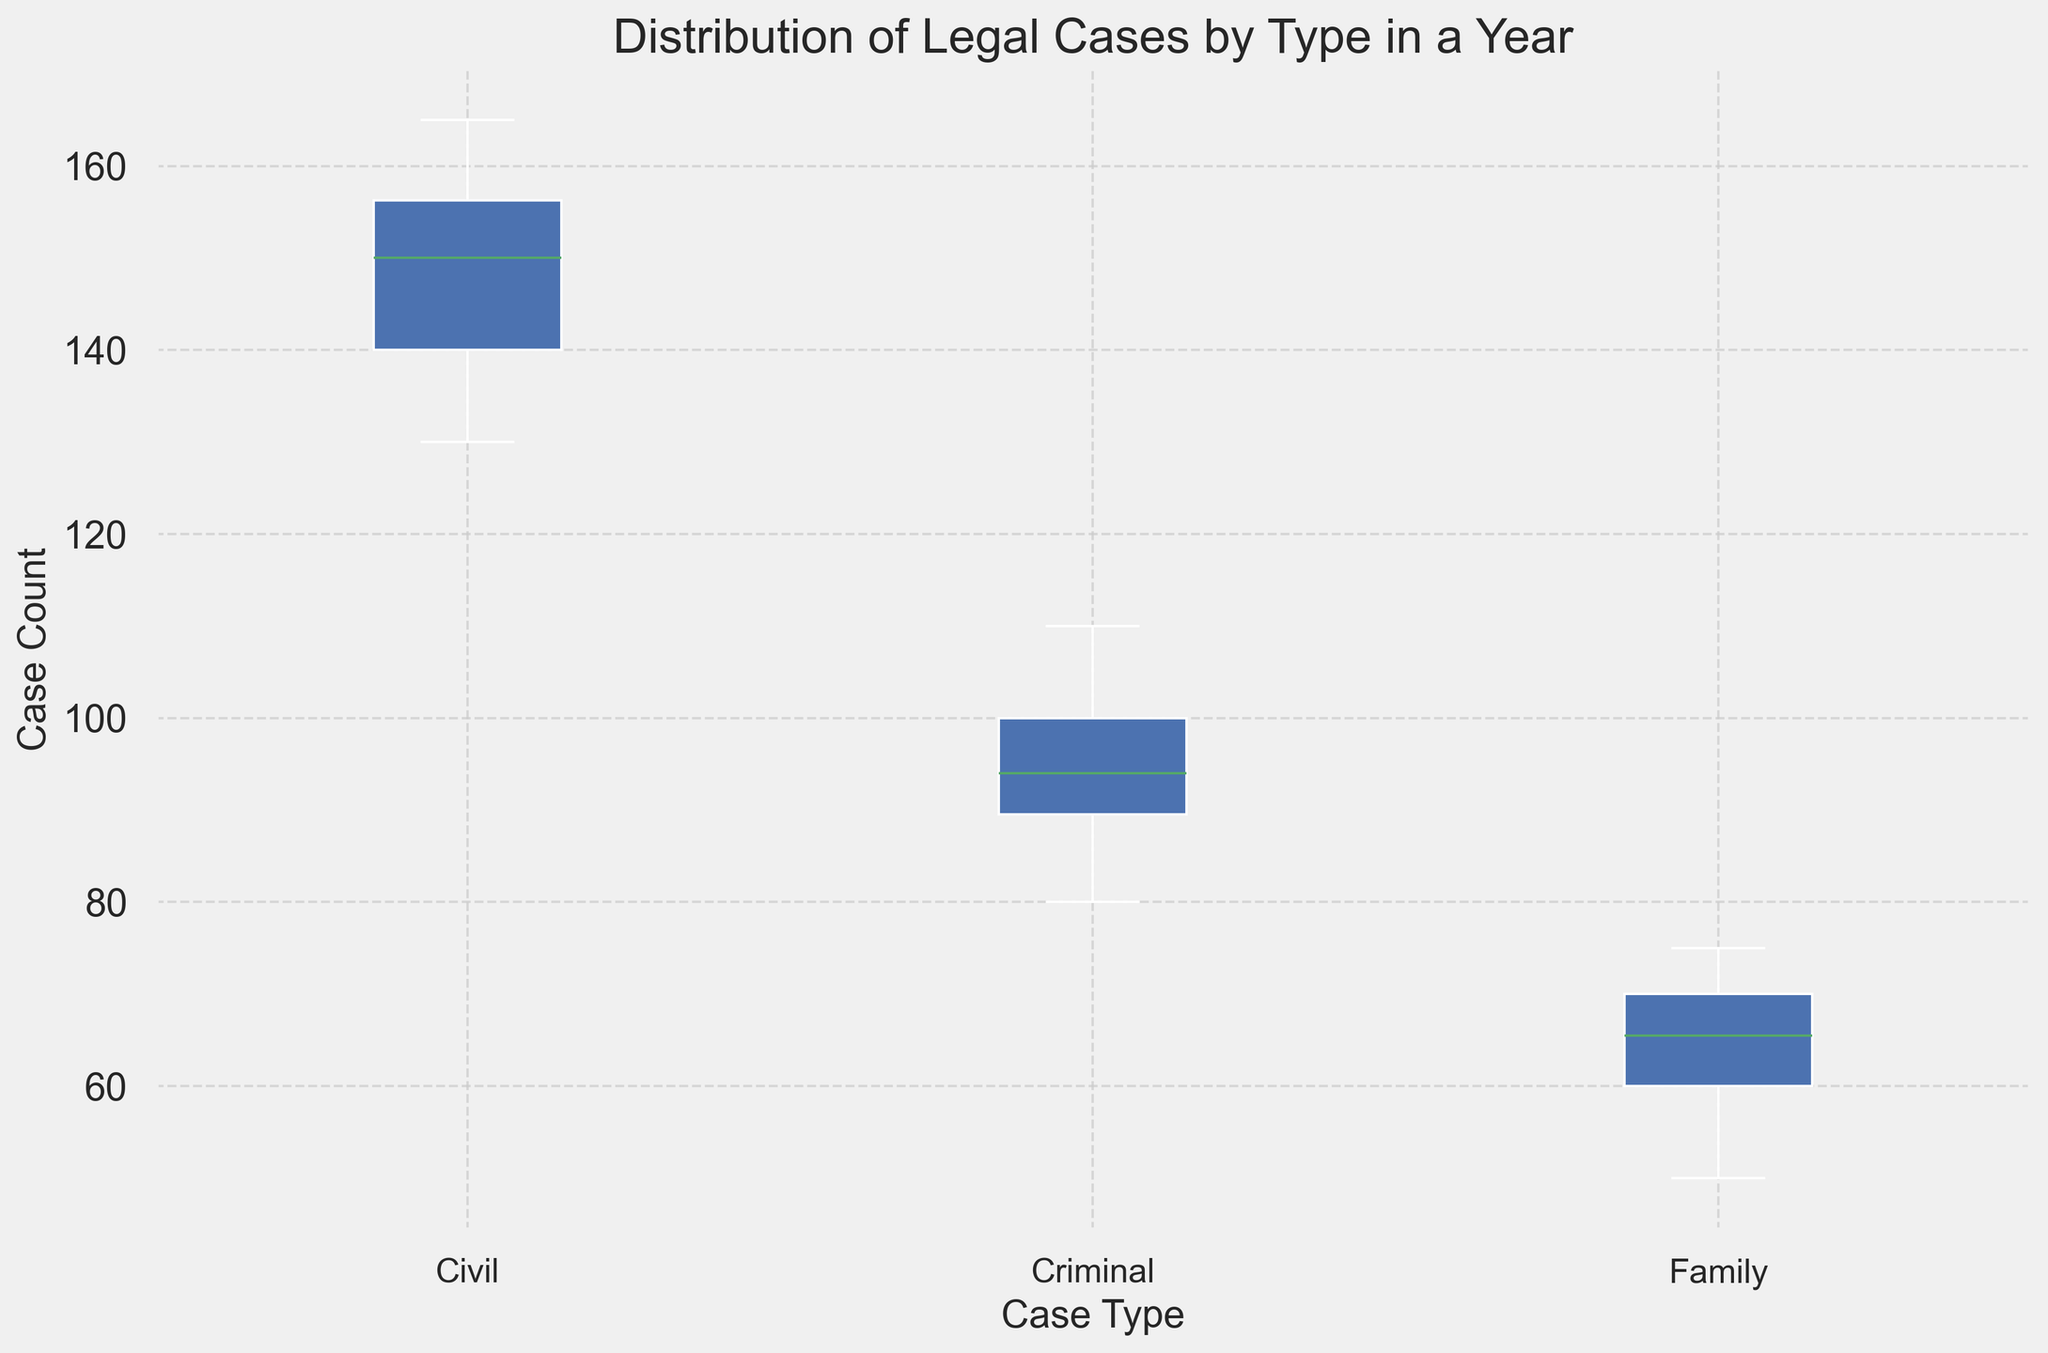What are the median values for civil, criminal, and family cases? Median values in a box plot are represented by the line inside the box for each case type. Estimate these lines' positions on the y-axis for each case type.
Answer: Civil: 150, Criminal: 95, Family: 65 Which case type has the highest variability in case counts? Variability in a box plot is shown by the length of the interquartile range (IQR) — the range between the 25th and 75th percentiles. Compare the lengths of the boxes for each case type.
Answer: Civil Are there any case types with outliers? Outliers in a box plot are typically represented by dots outside the "whiskers." Look for any dots outside the whiskers' range for each case type.
Answer: No Which case type has the highest median case count? The median value in a box plot is shown by the horizontal line inside the box. Compare the medians of each case type.
Answer: Civil Is the median case count for criminal cases higher than that for family cases? Compare the median lines of criminal and family cases to see which is higher.
Answer: Yes By roughly how many cases does the median civil case count exceed the median family case count? Subtract the median value of family cases from the median value of civil cases. Calculation: 150 (Civil Median) - 65 (Family Median) = 85
Answer: 85 Which case type has the smallest range in case counts? The range can be estimated by the distance between the smallest and largest dots (whiskers' ends). Compare the ranges of each case type.
Answer: Family From the box plot, is it possible to determine the average number of cases for each type? Why or why not? A box plot shows the distribution, including medians and quartiles, but does not provide explicit means (average values).
Answer: No How do the interquartile ranges (IQR) of criminal cases compare to those of civil cases? The IQR is the length of the box. Compare the IQRs' lengths for criminal and civil cases.
Answer: Criminal IQR is smaller What visual feature indicates the 25th percentile in the box plot for any case type? The 25th percentile is indicated by the bottom edge of the box for each case type.
Answer: Bottom edge of the box 